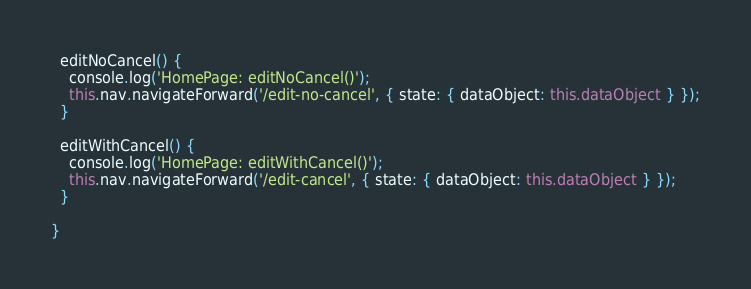<code> <loc_0><loc_0><loc_500><loc_500><_TypeScript_>  editNoCancel() {
    console.log('HomePage: editNoCancel()');
    this.nav.navigateForward('/edit-no-cancel', { state: { dataObject: this.dataObject } });
  }

  editWithCancel() {
    console.log('HomePage: editWithCancel()');
    this.nav.navigateForward('/edit-cancel', { state: { dataObject: this.dataObject } });
  }

}
</code> 